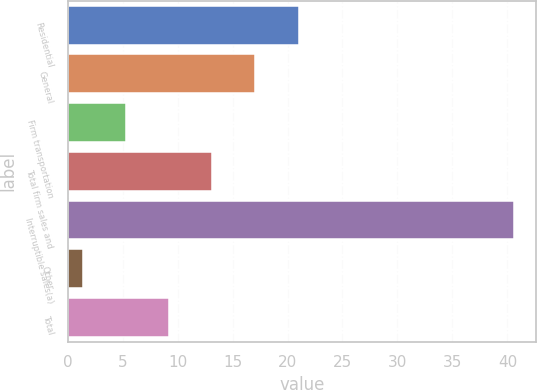<chart> <loc_0><loc_0><loc_500><loc_500><bar_chart><fcel>Residential<fcel>General<fcel>Firm transportation<fcel>Total firm sales and<fcel>Interruptible sales(a)<fcel>Other<fcel>Total<nl><fcel>21<fcel>17.08<fcel>5.32<fcel>13.16<fcel>40.6<fcel>1.4<fcel>9.24<nl></chart> 